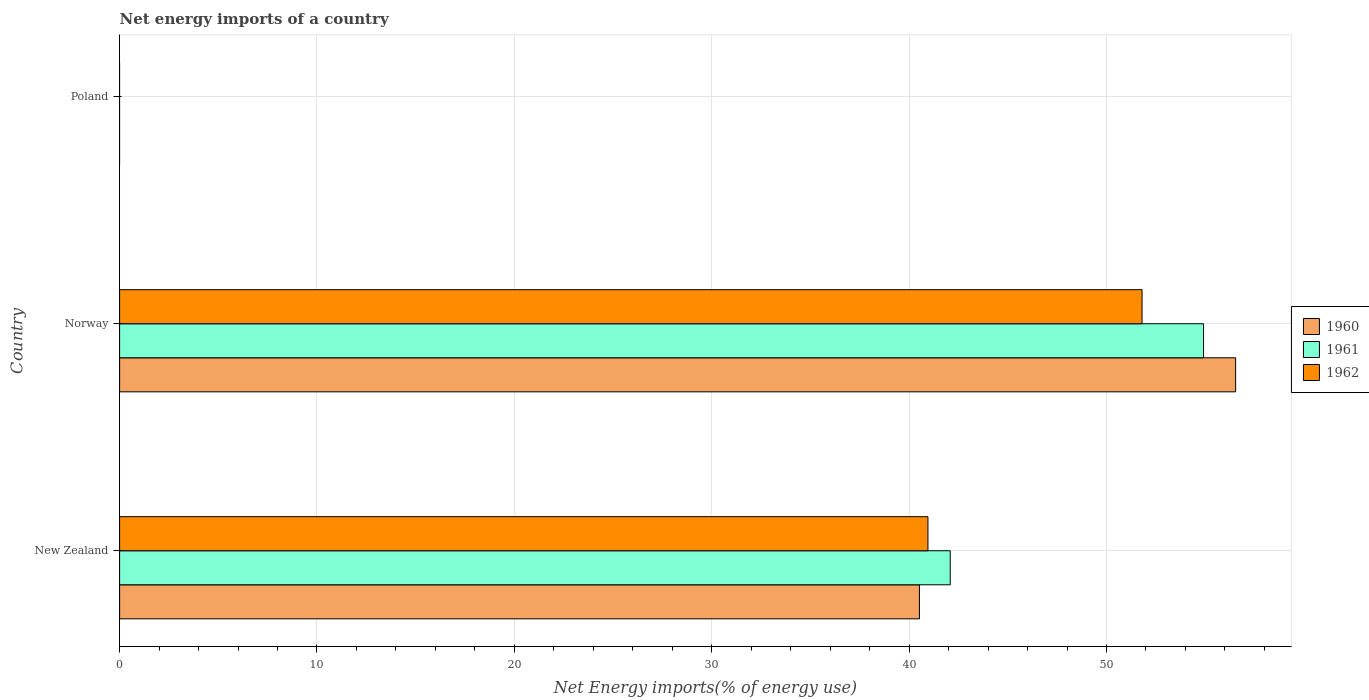How many different coloured bars are there?
Provide a short and direct response. 3. Are the number of bars on each tick of the Y-axis equal?
Make the answer very short. No. How many bars are there on the 3rd tick from the bottom?
Provide a short and direct response. 0. What is the label of the 2nd group of bars from the top?
Offer a terse response. Norway. What is the net energy imports in 1962 in Norway?
Your answer should be compact. 51.8. Across all countries, what is the maximum net energy imports in 1961?
Your response must be concise. 54.92. Across all countries, what is the minimum net energy imports in 1961?
Your answer should be very brief. 0. In which country was the net energy imports in 1960 maximum?
Offer a very short reply. Norway. What is the total net energy imports in 1962 in the graph?
Keep it short and to the point. 92.75. What is the difference between the net energy imports in 1961 in New Zealand and that in Norway?
Offer a very short reply. -12.83. What is the difference between the net energy imports in 1960 in New Zealand and the net energy imports in 1962 in Poland?
Make the answer very short. 40.52. What is the average net energy imports in 1960 per country?
Keep it short and to the point. 32.35. What is the difference between the net energy imports in 1962 and net energy imports in 1961 in New Zealand?
Keep it short and to the point. -1.13. What is the ratio of the net energy imports in 1961 in New Zealand to that in Norway?
Offer a terse response. 0.77. What is the difference between the highest and the lowest net energy imports in 1962?
Provide a short and direct response. 51.8. Is it the case that in every country, the sum of the net energy imports in 1962 and net energy imports in 1961 is greater than the net energy imports in 1960?
Provide a succinct answer. No. How many countries are there in the graph?
Keep it short and to the point. 3. Are the values on the major ticks of X-axis written in scientific E-notation?
Give a very brief answer. No. How many legend labels are there?
Your response must be concise. 3. How are the legend labels stacked?
Provide a succinct answer. Vertical. What is the title of the graph?
Make the answer very short. Net energy imports of a country. Does "2014" appear as one of the legend labels in the graph?
Offer a terse response. No. What is the label or title of the X-axis?
Provide a short and direct response. Net Energy imports(% of energy use). What is the label or title of the Y-axis?
Offer a terse response. Country. What is the Net Energy imports(% of energy use) of 1960 in New Zealand?
Your answer should be very brief. 40.52. What is the Net Energy imports(% of energy use) in 1961 in New Zealand?
Provide a short and direct response. 42.08. What is the Net Energy imports(% of energy use) of 1962 in New Zealand?
Provide a short and direct response. 40.95. What is the Net Energy imports(% of energy use) in 1960 in Norway?
Provide a short and direct response. 56.54. What is the Net Energy imports(% of energy use) in 1961 in Norway?
Give a very brief answer. 54.92. What is the Net Energy imports(% of energy use) of 1962 in Norway?
Make the answer very short. 51.8. What is the Net Energy imports(% of energy use) of 1960 in Poland?
Your response must be concise. 0. What is the Net Energy imports(% of energy use) in 1962 in Poland?
Give a very brief answer. 0. Across all countries, what is the maximum Net Energy imports(% of energy use) in 1960?
Provide a short and direct response. 56.54. Across all countries, what is the maximum Net Energy imports(% of energy use) in 1961?
Offer a terse response. 54.92. Across all countries, what is the maximum Net Energy imports(% of energy use) of 1962?
Your response must be concise. 51.8. What is the total Net Energy imports(% of energy use) of 1960 in the graph?
Provide a short and direct response. 97.06. What is the total Net Energy imports(% of energy use) in 1961 in the graph?
Your response must be concise. 97. What is the total Net Energy imports(% of energy use) of 1962 in the graph?
Offer a very short reply. 92.75. What is the difference between the Net Energy imports(% of energy use) of 1960 in New Zealand and that in Norway?
Keep it short and to the point. -16.02. What is the difference between the Net Energy imports(% of energy use) in 1961 in New Zealand and that in Norway?
Make the answer very short. -12.83. What is the difference between the Net Energy imports(% of energy use) in 1962 in New Zealand and that in Norway?
Your response must be concise. -10.85. What is the difference between the Net Energy imports(% of energy use) of 1960 in New Zealand and the Net Energy imports(% of energy use) of 1961 in Norway?
Provide a short and direct response. -14.39. What is the difference between the Net Energy imports(% of energy use) of 1960 in New Zealand and the Net Energy imports(% of energy use) of 1962 in Norway?
Give a very brief answer. -11.28. What is the difference between the Net Energy imports(% of energy use) in 1961 in New Zealand and the Net Energy imports(% of energy use) in 1962 in Norway?
Ensure brevity in your answer.  -9.72. What is the average Net Energy imports(% of energy use) in 1960 per country?
Your answer should be very brief. 32.35. What is the average Net Energy imports(% of energy use) of 1961 per country?
Your answer should be compact. 32.33. What is the average Net Energy imports(% of energy use) in 1962 per country?
Keep it short and to the point. 30.92. What is the difference between the Net Energy imports(% of energy use) of 1960 and Net Energy imports(% of energy use) of 1961 in New Zealand?
Ensure brevity in your answer.  -1.56. What is the difference between the Net Energy imports(% of energy use) of 1960 and Net Energy imports(% of energy use) of 1962 in New Zealand?
Ensure brevity in your answer.  -0.43. What is the difference between the Net Energy imports(% of energy use) of 1961 and Net Energy imports(% of energy use) of 1962 in New Zealand?
Your response must be concise. 1.13. What is the difference between the Net Energy imports(% of energy use) in 1960 and Net Energy imports(% of energy use) in 1961 in Norway?
Make the answer very short. 1.62. What is the difference between the Net Energy imports(% of energy use) of 1960 and Net Energy imports(% of energy use) of 1962 in Norway?
Your response must be concise. 4.74. What is the difference between the Net Energy imports(% of energy use) of 1961 and Net Energy imports(% of energy use) of 1962 in Norway?
Provide a short and direct response. 3.12. What is the ratio of the Net Energy imports(% of energy use) in 1960 in New Zealand to that in Norway?
Make the answer very short. 0.72. What is the ratio of the Net Energy imports(% of energy use) in 1961 in New Zealand to that in Norway?
Offer a very short reply. 0.77. What is the ratio of the Net Energy imports(% of energy use) in 1962 in New Zealand to that in Norway?
Make the answer very short. 0.79. What is the difference between the highest and the lowest Net Energy imports(% of energy use) in 1960?
Keep it short and to the point. 56.54. What is the difference between the highest and the lowest Net Energy imports(% of energy use) of 1961?
Ensure brevity in your answer.  54.92. What is the difference between the highest and the lowest Net Energy imports(% of energy use) of 1962?
Make the answer very short. 51.8. 